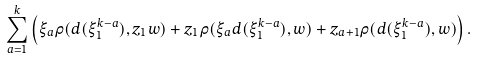Convert formula to latex. <formula><loc_0><loc_0><loc_500><loc_500>\sum _ { a = 1 } ^ { k } \left ( \xi _ { a } \rho ( d ( \xi _ { 1 } ^ { k - a } ) , z _ { 1 } w ) + z _ { 1 } \rho ( \xi _ { a } d ( \xi _ { 1 } ^ { k - a } ) , w ) + z _ { a + 1 } \rho ( d ( \xi _ { 1 } ^ { k - a } ) , w ) \right ) .</formula> 